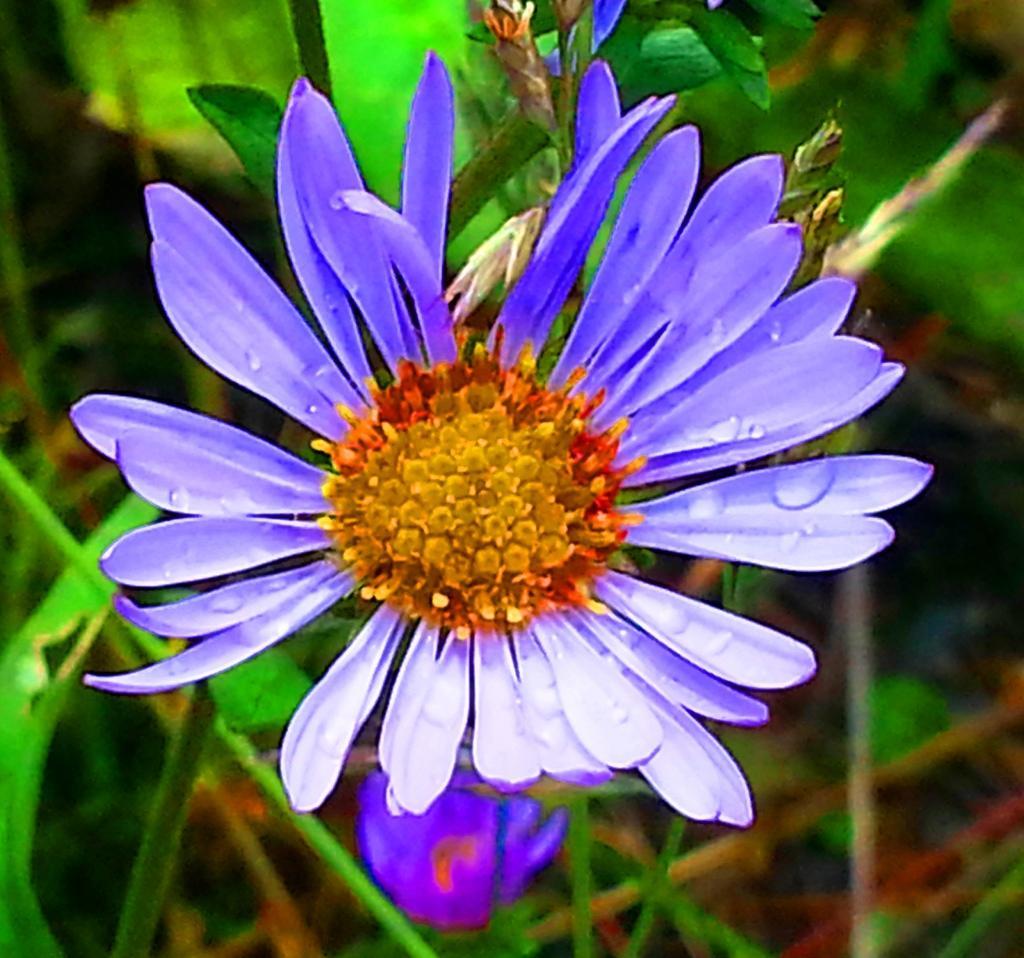Please provide a concise description of this image. In this picture there is a flower in the center of the image and there is greenery in the background area of the image. 